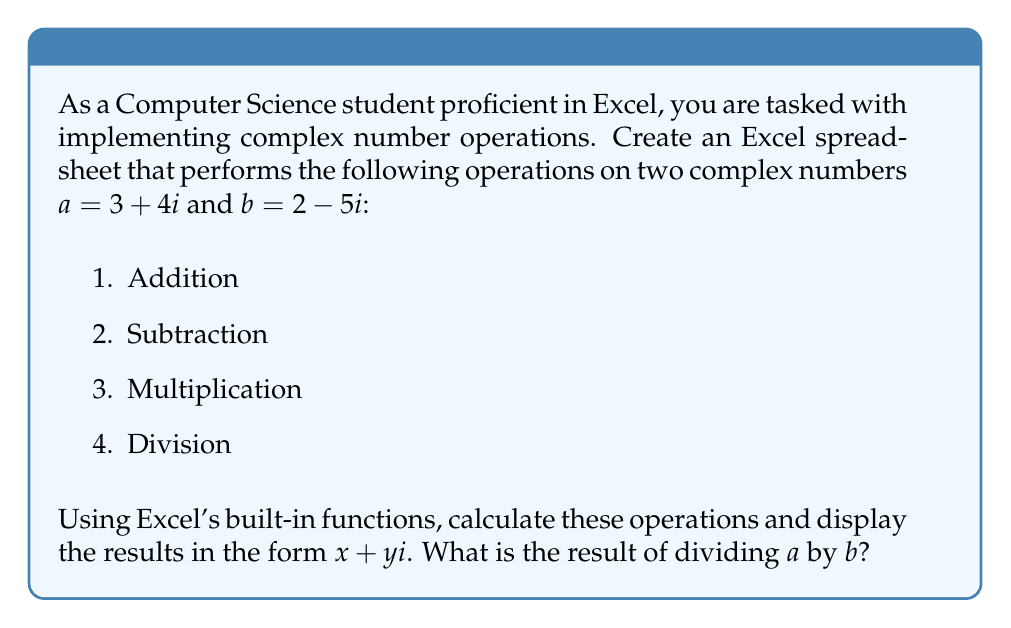Show me your answer to this math problem. To implement complex number operations in Excel using built-in functions, we can use the COMPLEX, IMSUM, IMSUB, IMPRODUCT, and IMDIV functions. Here's how to set up the spreadsheet and perform the calculations:

1. Enter the complex numbers:
   - In cell A1, enter: =COMPLEX(3,4)
   - In cell A2, enter: =COMPLEX(2,-5)

2. Perform the operations:
   - Addition (A3): =IMSUM(A1,A2)
   - Subtraction (A4): =IMSUB(A1,A2)
   - Multiplication (A5): =IMPRODUCT(A1,A2)
   - Division (A6): =IMDIV(A1,A2)

3. To display the results in the form $x + yi$, use the IMREAL and IMAGINARY functions:
   - For the real part: =IMREAL(result_cell)
   - For the imaginary part: =IMAGINARY(result_cell)

For the division of $a$ by $b$, we focus on cell A6. The result will be in the form $x + yi$, where:

$$\frac{a}{b} = \frac{(3+4i)(2+5i)}{(2-5i)(2+5i)} = \frac{6+15i+8i-20i^2}{4+25} = \frac{26+23i}{29}$$

Simplifying:

$$\frac{a}{b} = \frac{26}{29} + \frac{23}{29}i \approx 0.8966 + 0.7931i$$

This matches the result we would get from Excel's IMDIV function.
Answer: The result of dividing $a$ by $b$ is approximately $0.8966 + 0.7931i$. 